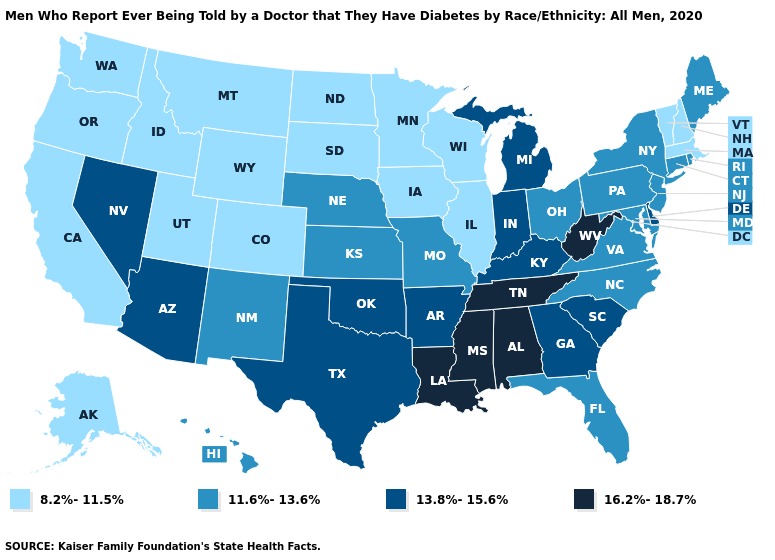What is the lowest value in states that border Indiana?
Concise answer only. 8.2%-11.5%. What is the value of Colorado?
Answer briefly. 8.2%-11.5%. Which states have the lowest value in the MidWest?
Quick response, please. Illinois, Iowa, Minnesota, North Dakota, South Dakota, Wisconsin. Does Delaware have the same value as Michigan?
Quick response, please. Yes. How many symbols are there in the legend?
Be succinct. 4. Name the states that have a value in the range 8.2%-11.5%?
Keep it brief. Alaska, California, Colorado, Idaho, Illinois, Iowa, Massachusetts, Minnesota, Montana, New Hampshire, North Dakota, Oregon, South Dakota, Utah, Vermont, Washington, Wisconsin, Wyoming. How many symbols are there in the legend?
Short answer required. 4. Among the states that border Vermont , which have the lowest value?
Quick response, please. Massachusetts, New Hampshire. What is the lowest value in states that border Montana?
Write a very short answer. 8.2%-11.5%. Name the states that have a value in the range 16.2%-18.7%?
Answer briefly. Alabama, Louisiana, Mississippi, Tennessee, West Virginia. Among the states that border Kentucky , does Tennessee have the highest value?
Answer briefly. Yes. Does Virginia have the lowest value in the USA?
Concise answer only. No. Does Tennessee have the highest value in the South?
Keep it brief. Yes. Does the first symbol in the legend represent the smallest category?
Concise answer only. Yes. How many symbols are there in the legend?
Keep it brief. 4. 